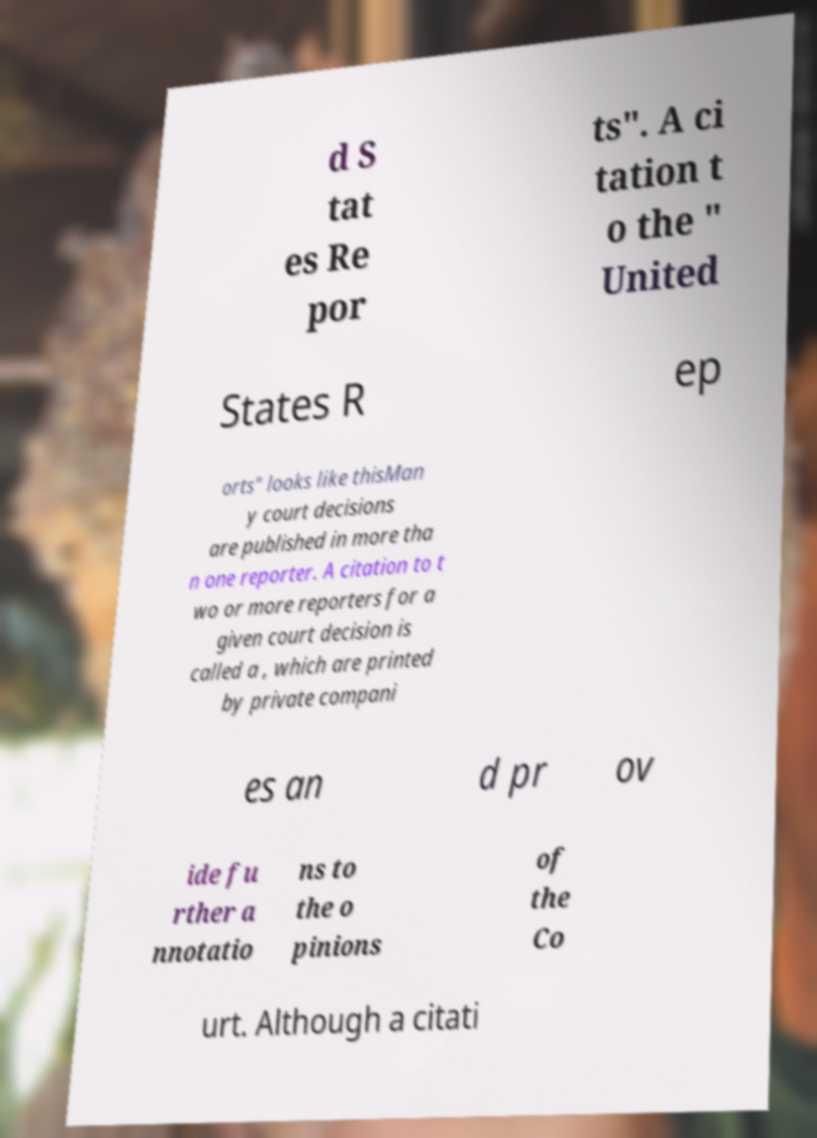There's text embedded in this image that I need extracted. Can you transcribe it verbatim? d S tat es Re por ts". A ci tation t o the " United States R ep orts" looks like thisMan y court decisions are published in more tha n one reporter. A citation to t wo or more reporters for a given court decision is called a , which are printed by private compani es an d pr ov ide fu rther a nnotatio ns to the o pinions of the Co urt. Although a citati 